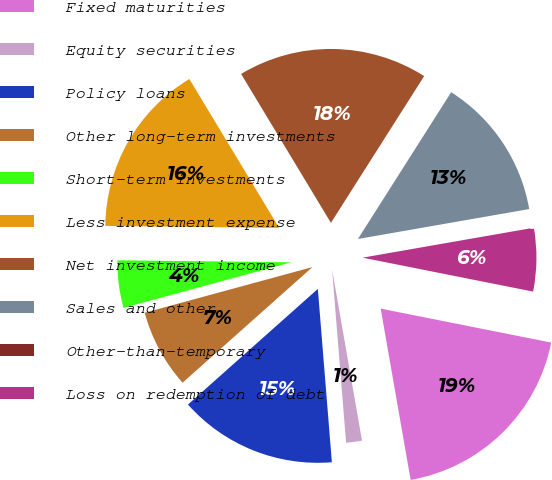Convert chart to OTSL. <chart><loc_0><loc_0><loc_500><loc_500><pie_chart><fcel>Fixed maturities<fcel>Equity securities<fcel>Policy loans<fcel>Other long-term investments<fcel>Short-term investments<fcel>Less investment expense<fcel>Net investment income<fcel>Sales and other<fcel>Other-than-temporary<fcel>Loss on redemption of debt<nl><fcel>19.12%<fcel>1.47%<fcel>14.71%<fcel>7.35%<fcel>4.41%<fcel>16.18%<fcel>17.65%<fcel>13.24%<fcel>0.0%<fcel>5.88%<nl></chart> 